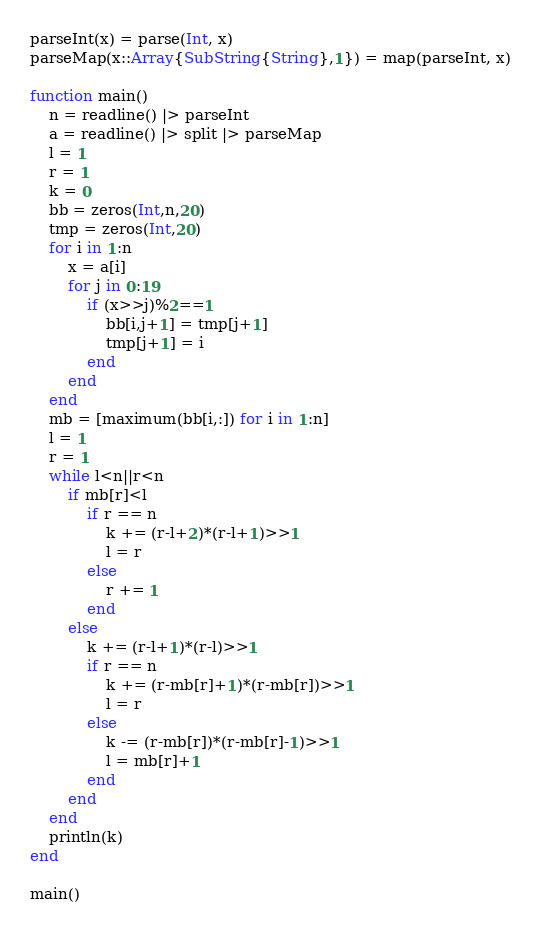Convert code to text. <code><loc_0><loc_0><loc_500><loc_500><_Julia_>parseInt(x) = parse(Int, x)
parseMap(x::Array{SubString{String},1}) = map(parseInt, x)

function main()
	n = readline() |> parseInt
	a = readline() |> split |> parseMap
	l = 1
	r = 1
	k = 0
	bb = zeros(Int,n,20)
	tmp = zeros(Int,20)
	for i in 1:n
		x = a[i]
		for j in 0:19
			if (x>>j)%2==1
				bb[i,j+1] = tmp[j+1]
				tmp[j+1] = i
			end
		end
	end
	mb = [maximum(bb[i,:]) for i in 1:n]
	l = 1
	r = 1
	while l<n||r<n
		if mb[r]<l
			if r == n
				k += (r-l+2)*(r-l+1)>>1
				l = r
			else
				r += 1
			end
		else
			k += (r-l+1)*(r-l)>>1
			if r == n
				k += (r-mb[r]+1)*(r-mb[r])>>1
				l = r
			else
				k -= (r-mb[r])*(r-mb[r]-1)>>1
				l = mb[r]+1
			end
		end
	end
	println(k)
end

main()</code> 